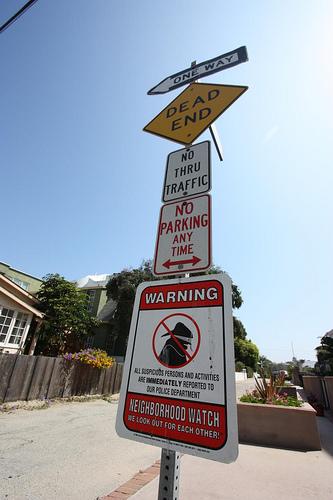Are those signs obeyed?
Concise answer only. Yes. Is this area safe?
Be succinct. Yes. What does the sign say?
Be succinct. Dead end. 